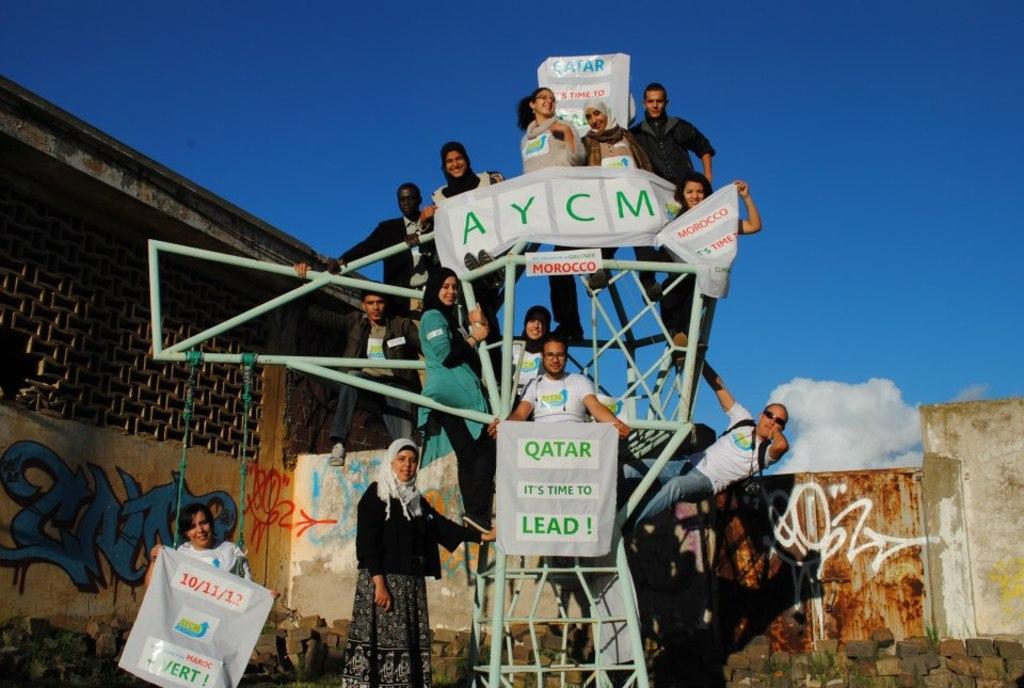Please provide a concise description of this image. In this picture we can see a group of people standing and smiling were some are holding posters with their hands on a stand, shed, wall with a painting on it and in the background we can see the sky with clouds. 